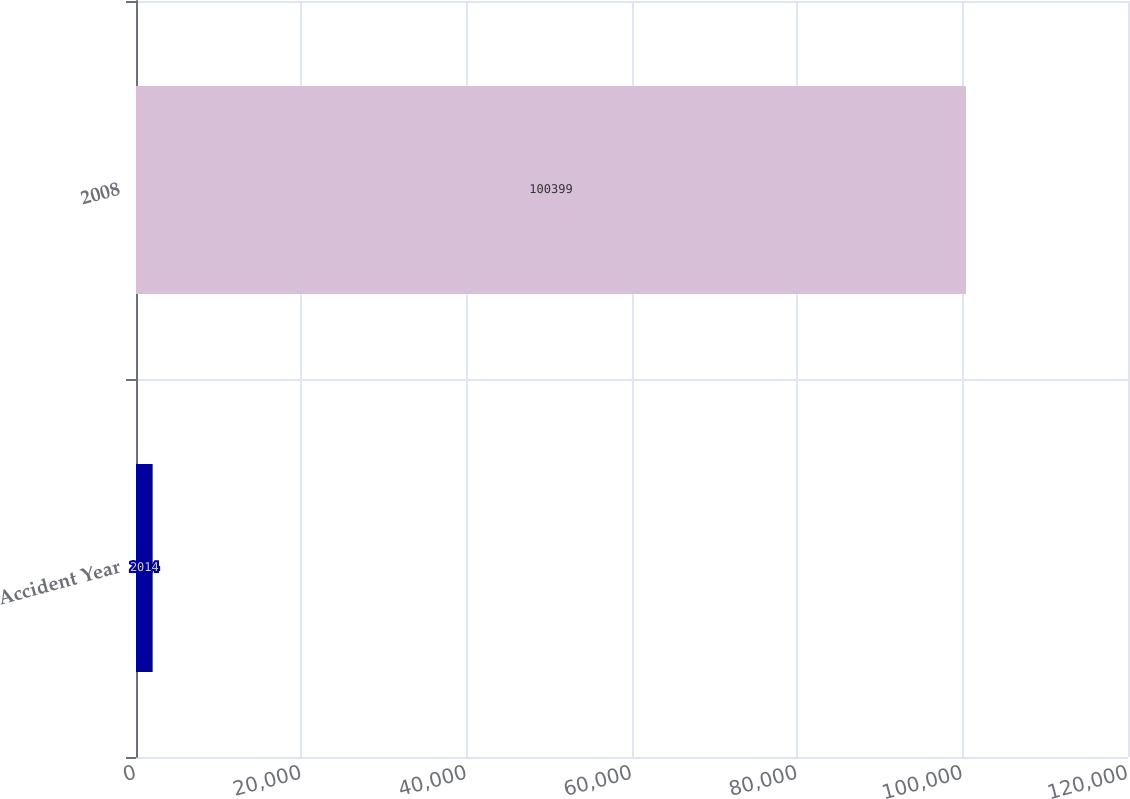Convert chart to OTSL. <chart><loc_0><loc_0><loc_500><loc_500><bar_chart><fcel>Accident Year<fcel>2008<nl><fcel>2014<fcel>100399<nl></chart> 